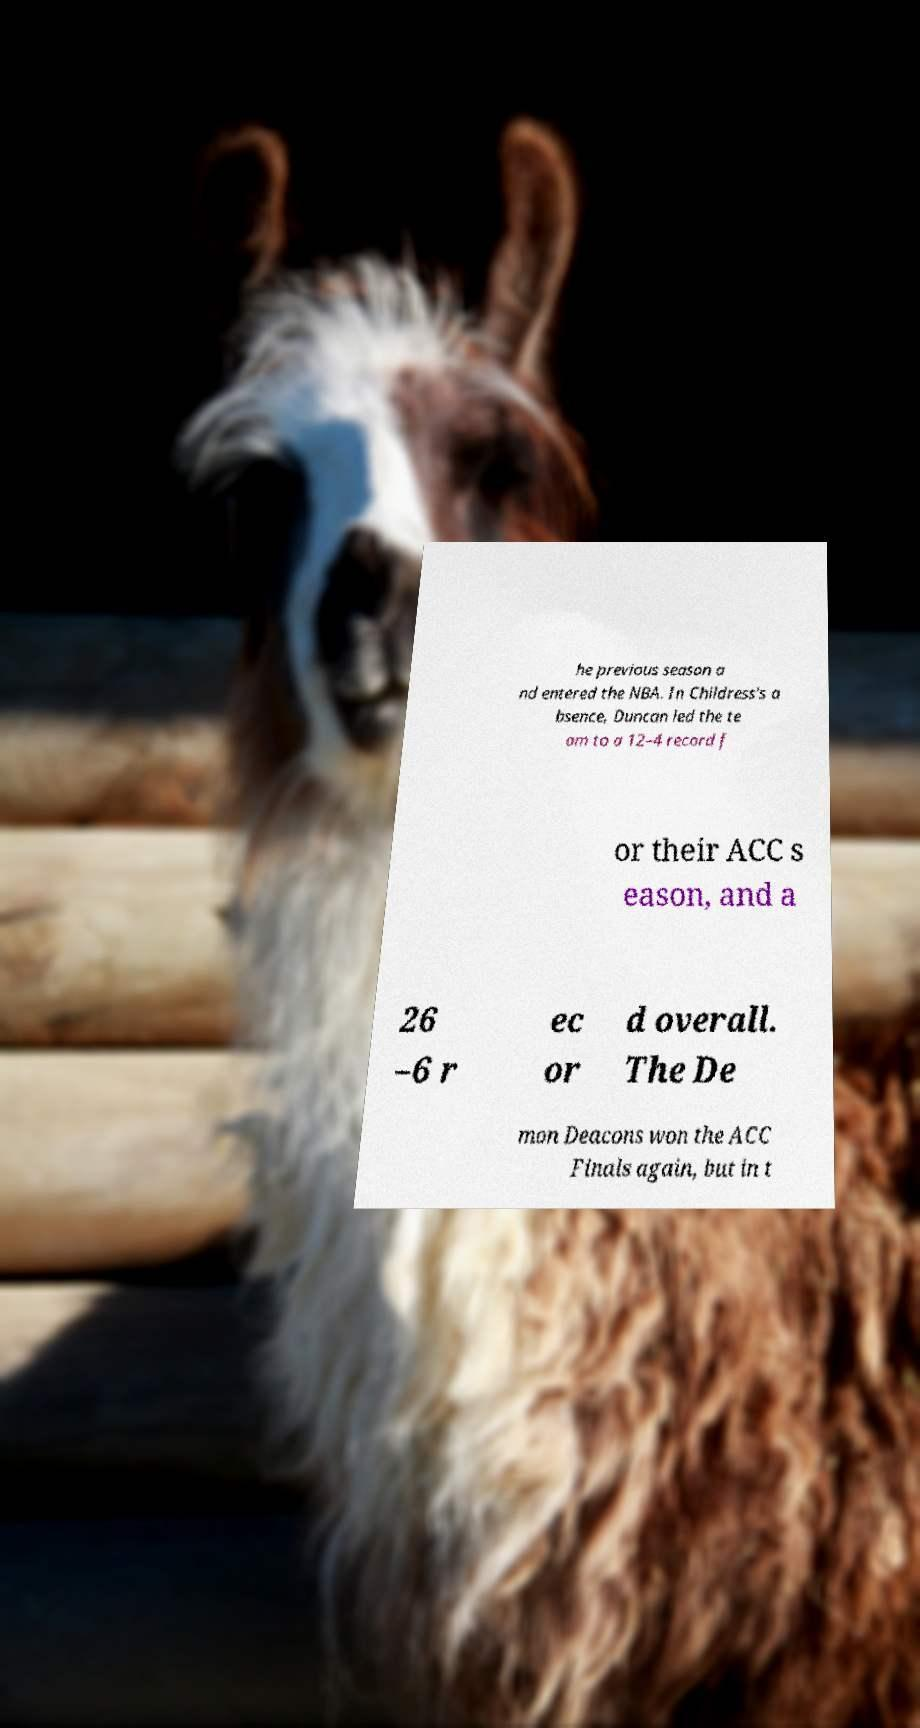I need the written content from this picture converted into text. Can you do that? he previous season a nd entered the NBA. In Childress's a bsence, Duncan led the te am to a 12–4 record f or their ACC s eason, and a 26 –6 r ec or d overall. The De mon Deacons won the ACC Finals again, but in t 